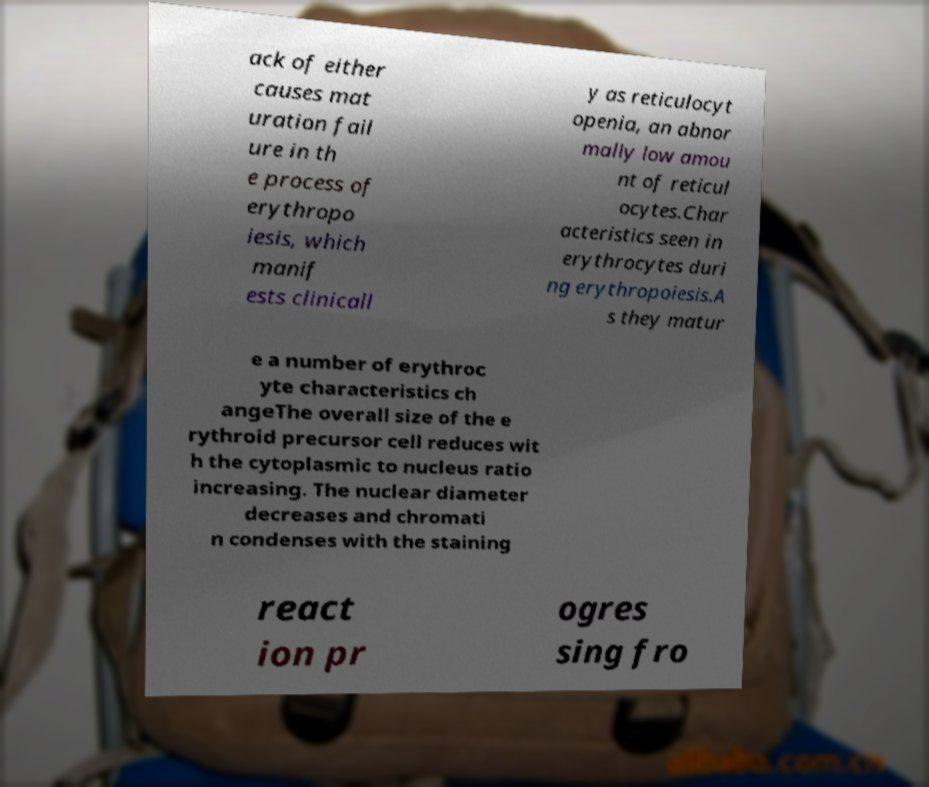Can you accurately transcribe the text from the provided image for me? ack of either causes mat uration fail ure in th e process of erythropo iesis, which manif ests clinicall y as reticulocyt openia, an abnor mally low amou nt of reticul ocytes.Char acteristics seen in erythrocytes duri ng erythropoiesis.A s they matur e a number of erythroc yte characteristics ch angeThe overall size of the e rythroid precursor cell reduces wit h the cytoplasmic to nucleus ratio increasing. The nuclear diameter decreases and chromati n condenses with the staining react ion pr ogres sing fro 